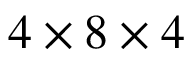Convert formula to latex. <formula><loc_0><loc_0><loc_500><loc_500>4 \times 8 \times 4</formula> 